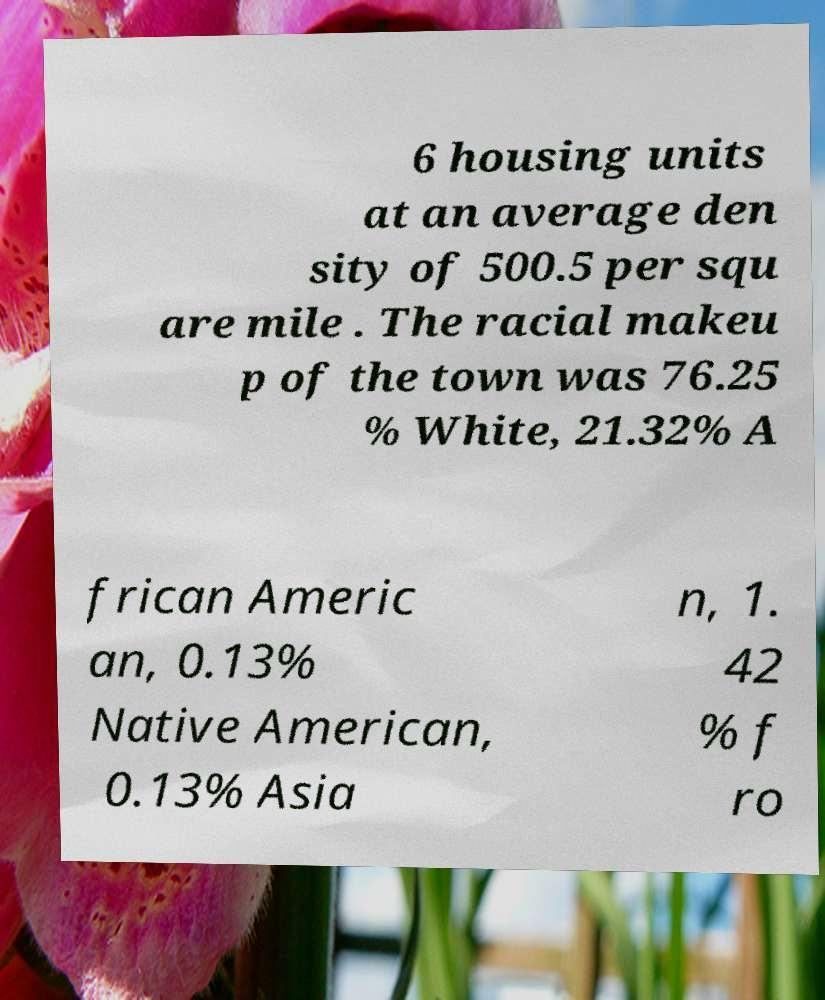Could you assist in decoding the text presented in this image and type it out clearly? 6 housing units at an average den sity of 500.5 per squ are mile . The racial makeu p of the town was 76.25 % White, 21.32% A frican Americ an, 0.13% Native American, 0.13% Asia n, 1. 42 % f ro 